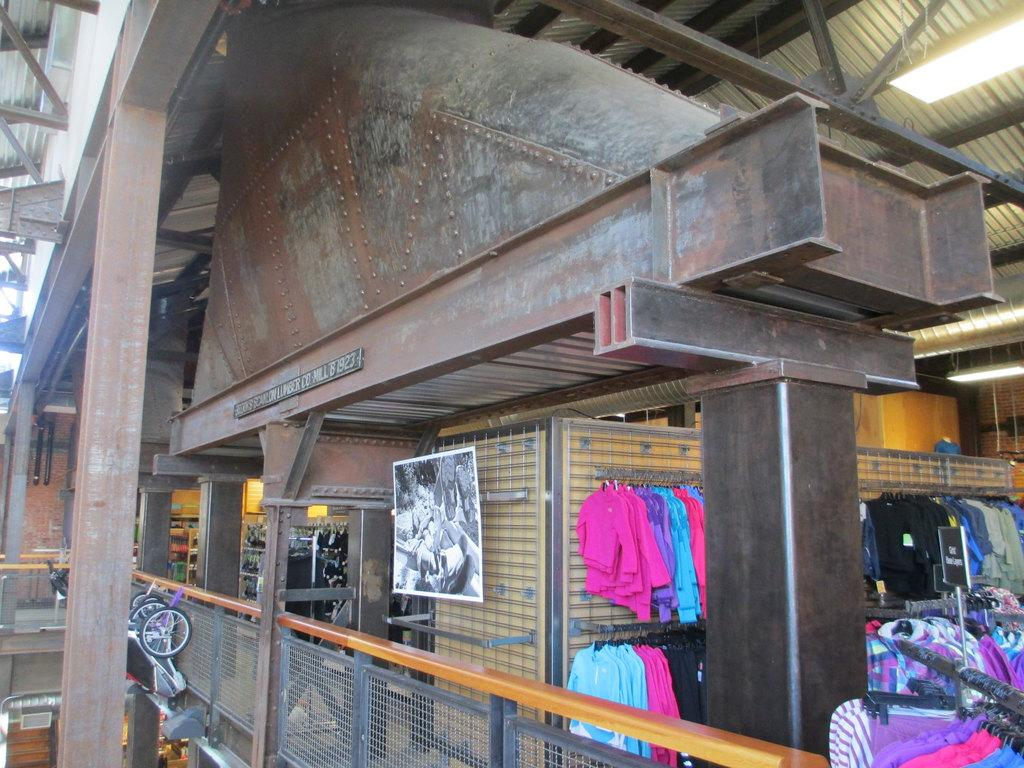What type of items can be seen in the image? There are clothes, lights, metal rods, carts, and a fence present in the image. Can you describe the lights in the image? The lights are visible in the image, but their specific characteristics are not mentioned in the facts. What are the metal rods used for in the image? The purpose of the metal rods is not mentioned in the facts, but they are visible in the image. How many carts are present in the image? The number of carts is not mentioned in the facts, but there are carts visible in the image. Can you see the farmer tending to the crops near the fence in the image? There is no farmer or crops mentioned in the facts, and therefore no such activity can be observed in the image. 